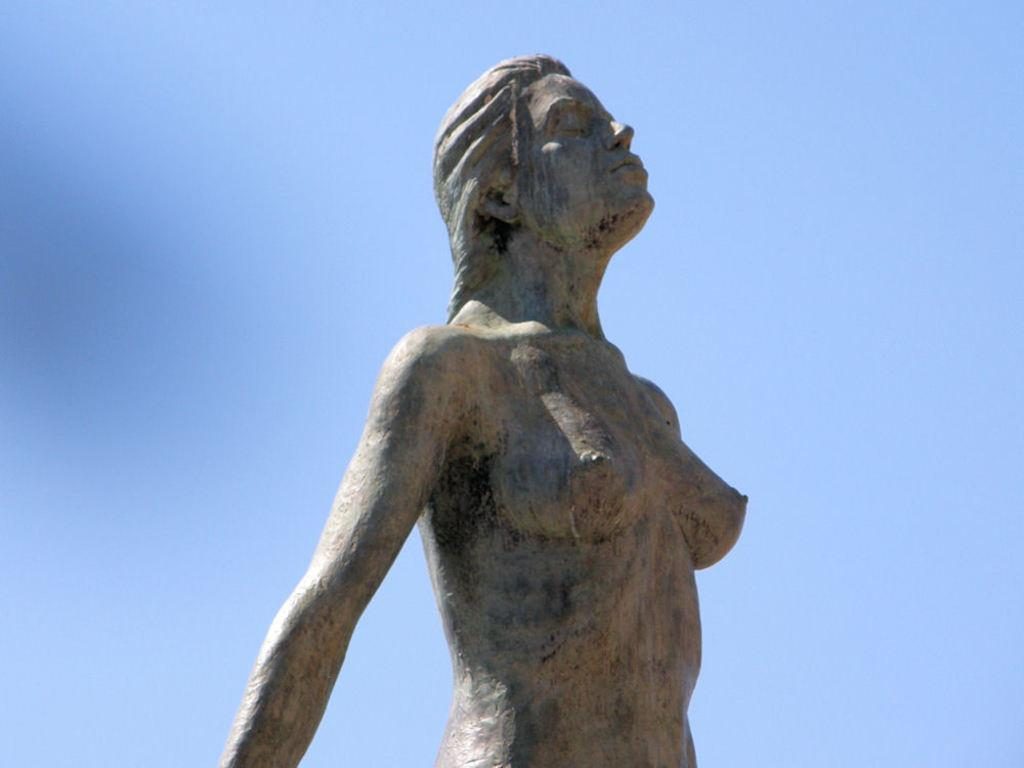What is the main subject of the image? There is a statue of a woman in the image. What can be seen in the background of the image? The sky is visible in the background of the image. What type of flag is being waved by the woman in the image? There is no flag or waving motion present in the image; it features a statue of a woman. What do you believe the woman's teeth look like in the image? The image does not show the woman's teeth, as it is a statue. 